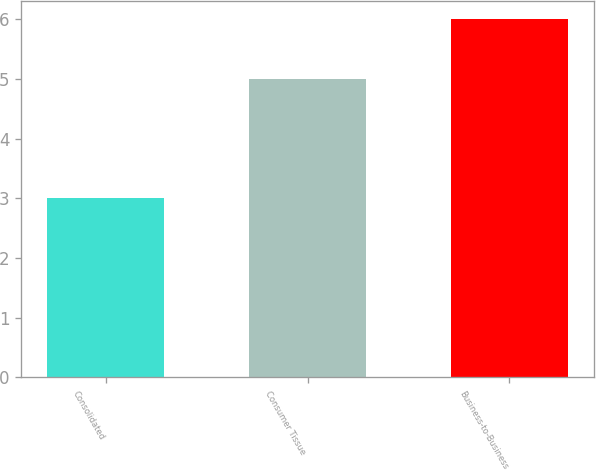Convert chart to OTSL. <chart><loc_0><loc_0><loc_500><loc_500><bar_chart><fcel>Consolidated<fcel>Consumer Tissue<fcel>Business-to-Business<nl><fcel>3<fcel>5<fcel>6<nl></chart> 